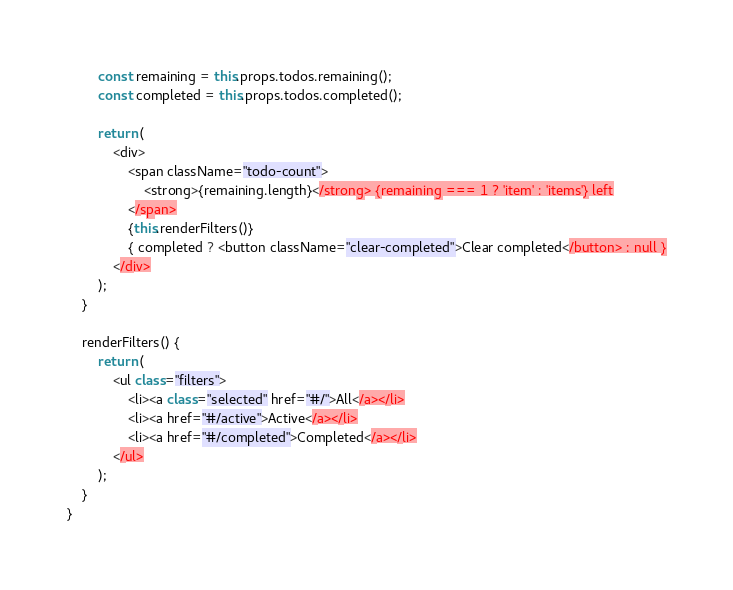<code> <loc_0><loc_0><loc_500><loc_500><_JavaScript_>        const remaining = this.props.todos.remaining();
        const completed = this.props.todos.completed();

        return (
            <div>
                <span className="todo-count">
                    <strong>{remaining.length}</strong> {remaining === 1 ? 'item' : 'items'} left
                </span>
                {this.renderFilters()}
                { completed ? <button className="clear-completed">Clear completed</button> : null }
            </div>
        );
    }

    renderFilters() {
        return (
            <ul class="filters">
                <li><a class="selected" href="#/">All</a></li>
                <li><a href="#/active">Active</a></li>
                <li><a href="#/completed">Completed</a></li>
            </ul>
        );
    }
}
</code> 